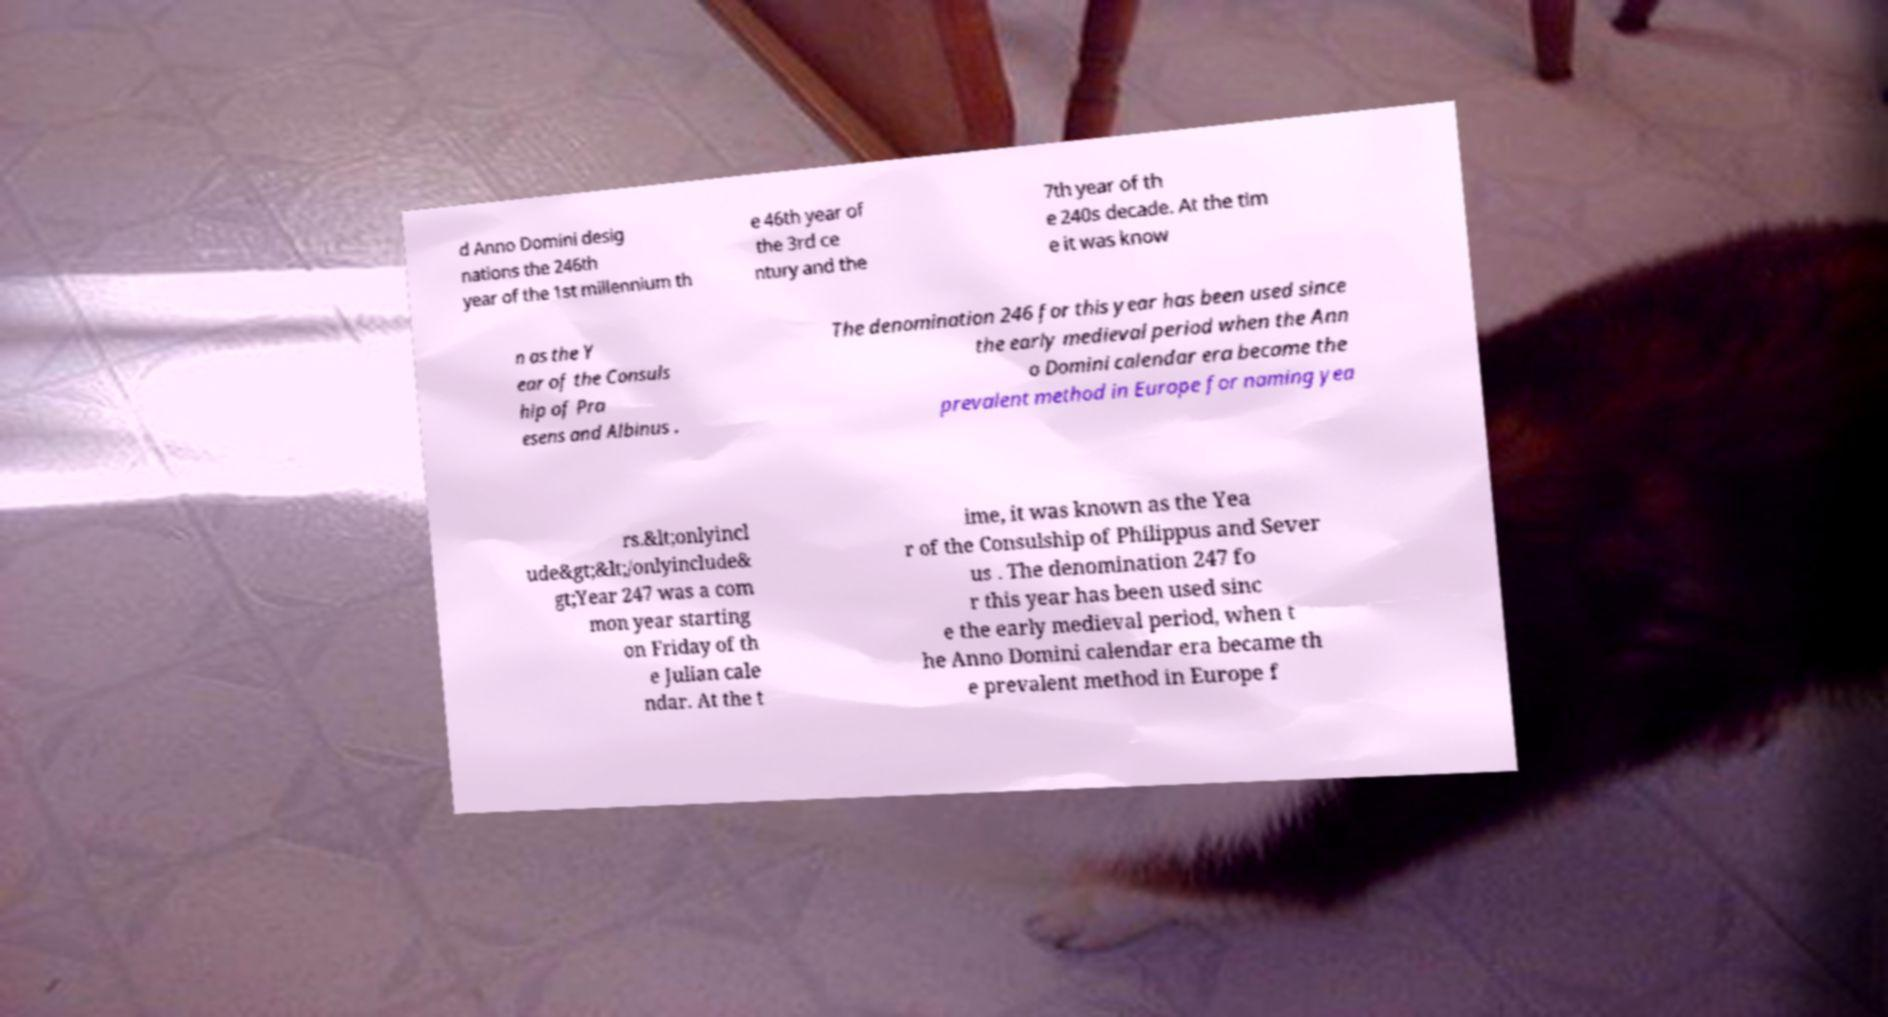What messages or text are displayed in this image? I need them in a readable, typed format. d Anno Domini desig nations the 246th year of the 1st millennium th e 46th year of the 3rd ce ntury and the 7th year of th e 240s decade. At the tim e it was know n as the Y ear of the Consuls hip of Pra esens and Albinus . The denomination 246 for this year has been used since the early medieval period when the Ann o Domini calendar era became the prevalent method in Europe for naming yea rs.&lt;onlyincl ude&gt;&lt;/onlyinclude& gt;Year 247 was a com mon year starting on Friday of th e Julian cale ndar. At the t ime, it was known as the Yea r of the Consulship of Philippus and Sever us . The denomination 247 fo r this year has been used sinc e the early medieval period, when t he Anno Domini calendar era became th e prevalent method in Europe f 